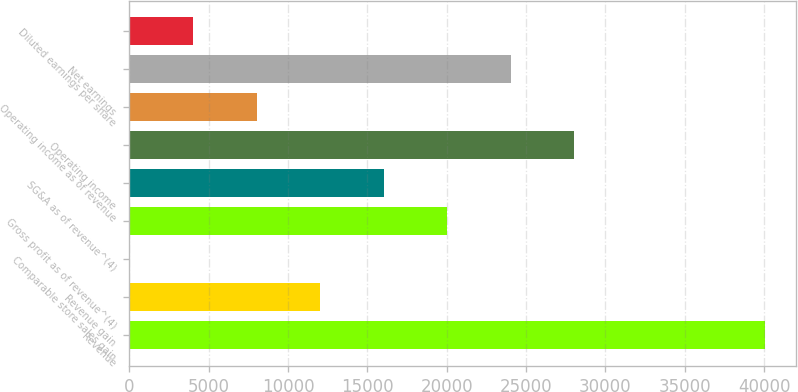Convert chart. <chart><loc_0><loc_0><loc_500><loc_500><bar_chart><fcel>Revenue<fcel>Revenue gain<fcel>Comparable store sales gain<fcel>Gross profit as of revenue^(4)<fcel>SG&A as of revenue^(4)<fcel>Operating income<fcel>Operating income as of revenue<fcel>Net earnings<fcel>Diluted earnings per share<nl><fcel>40023<fcel>12008.9<fcel>2.9<fcel>20013<fcel>16010.9<fcel>28017<fcel>8006.92<fcel>24015<fcel>4004.91<nl></chart> 